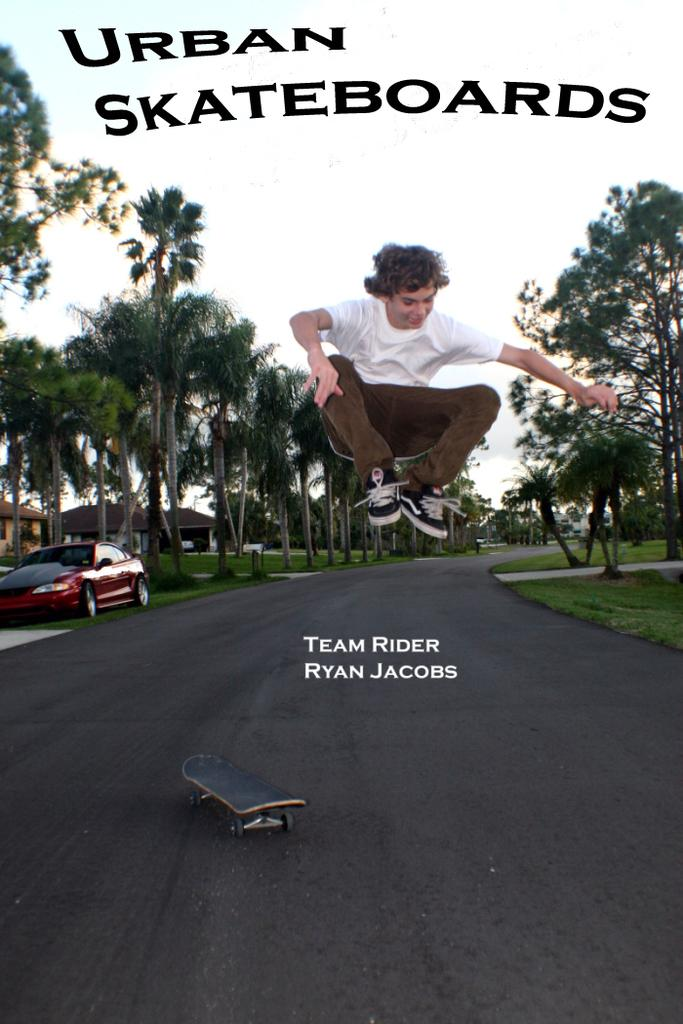What is the person in the image doing? The person is jumping in the image. What object is associated with the person in the image? There is a skateboard in the image. What type of vehicle is parked in the image? There is a car parked in the image. What type of vegetation is present in the image? There are trees in the image. What type of surface is visible in the image? There is a road in the image. What is visible in the background of the image? The sky is visible in the image. What type of letter is the maid holding in the image? There is no maid or letter present in the image. 